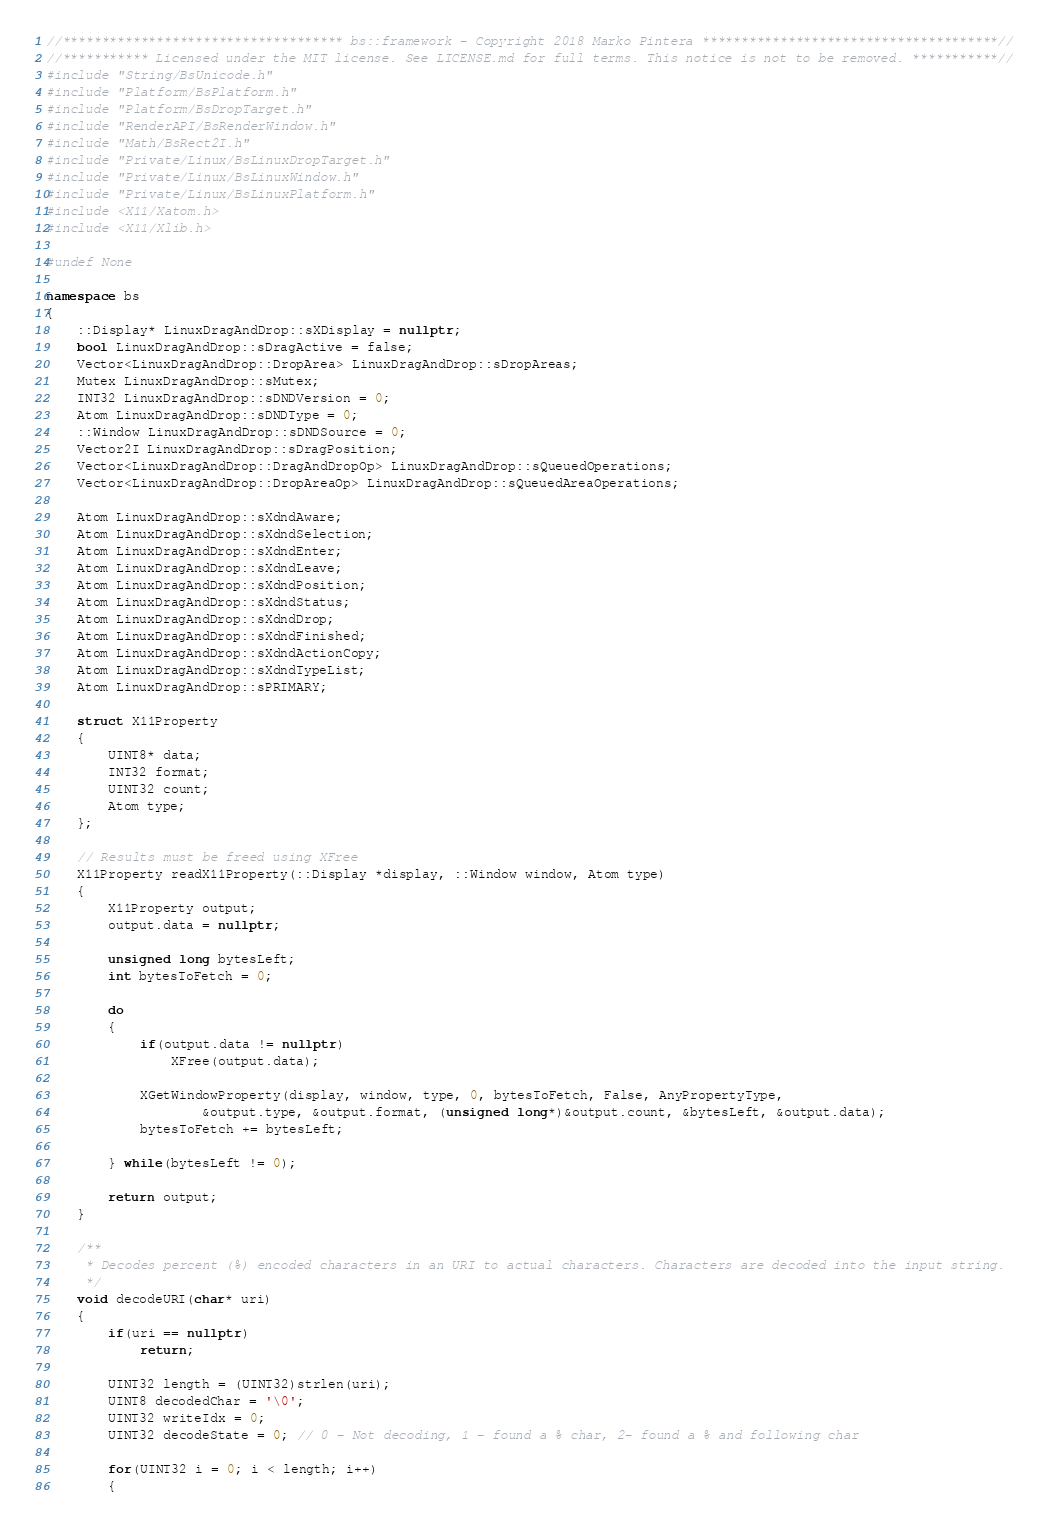Convert code to text. <code><loc_0><loc_0><loc_500><loc_500><_C++_>//************************************ bs::framework - Copyright 2018 Marko Pintera **************************************//
//*********** Licensed under the MIT license. See LICENSE.md for full terms. This notice is not to be removed. ***********//
#include "String/BsUnicode.h"
#include "Platform/BsPlatform.h"
#include "Platform/BsDropTarget.h"
#include "RenderAPI/BsRenderWindow.h"
#include "Math/BsRect2I.h"
#include "Private/Linux/BsLinuxDropTarget.h"
#include "Private/Linux/BsLinuxWindow.h"
#include "Private/Linux/BsLinuxPlatform.h"
#include <X11/Xatom.h>
#include <X11/Xlib.h>

#undef None

namespace bs
{
	::Display* LinuxDragAndDrop::sXDisplay = nullptr;
	bool LinuxDragAndDrop::sDragActive = false;
	Vector<LinuxDragAndDrop::DropArea> LinuxDragAndDrop::sDropAreas;
	Mutex LinuxDragAndDrop::sMutex;
	INT32 LinuxDragAndDrop::sDNDVersion = 0;
	Atom LinuxDragAndDrop::sDNDType = 0;
	::Window LinuxDragAndDrop::sDNDSource = 0;
	Vector2I LinuxDragAndDrop::sDragPosition;
	Vector<LinuxDragAndDrop::DragAndDropOp> LinuxDragAndDrop::sQueuedOperations;
	Vector<LinuxDragAndDrop::DropAreaOp> LinuxDragAndDrop::sQueuedAreaOperations;

	Atom LinuxDragAndDrop::sXdndAware;
	Atom LinuxDragAndDrop::sXdndSelection;
	Atom LinuxDragAndDrop::sXdndEnter;
	Atom LinuxDragAndDrop::sXdndLeave;
	Atom LinuxDragAndDrop::sXdndPosition;
	Atom LinuxDragAndDrop::sXdndStatus;
	Atom LinuxDragAndDrop::sXdndDrop;
	Atom LinuxDragAndDrop::sXdndFinished;
	Atom LinuxDragAndDrop::sXdndActionCopy;
	Atom LinuxDragAndDrop::sXdndTypeList;
	Atom LinuxDragAndDrop::sPRIMARY;

	struct X11Property
	{
		UINT8* data;
		INT32 format;
		UINT32 count;
		Atom type;
	};

	// Results must be freed using XFree
	X11Property readX11Property(::Display *display, ::Window window, Atom type)
	{
		X11Property output;
		output.data = nullptr;

		unsigned long bytesLeft;
		int bytesToFetch = 0;

		do
		{
			if(output.data != nullptr)
				XFree(output.data);

			XGetWindowProperty(display, window, type, 0, bytesToFetch, False, AnyPropertyType,
					&output.type, &output.format, (unsigned long*)&output.count, &bytesLeft, &output.data);
			bytesToFetch += bytesLeft;

		} while(bytesLeft != 0);

		return output;
	}

	/**
	 * Decodes percent (%) encoded characters in an URI to actual characters. Characters are decoded into the input string.
	 */
	void decodeURI(char* uri)
	{
		if(uri == nullptr)
			return;

		UINT32 length = (UINT32)strlen(uri);
		UINT8 decodedChar = '\0';
		UINT32 writeIdx = 0;
		UINT32 decodeState = 0; // 0 - Not decoding, 1 - found a % char, 2- found a % and following char

		for(UINT32 i = 0; i < length; i++)
		{</code> 